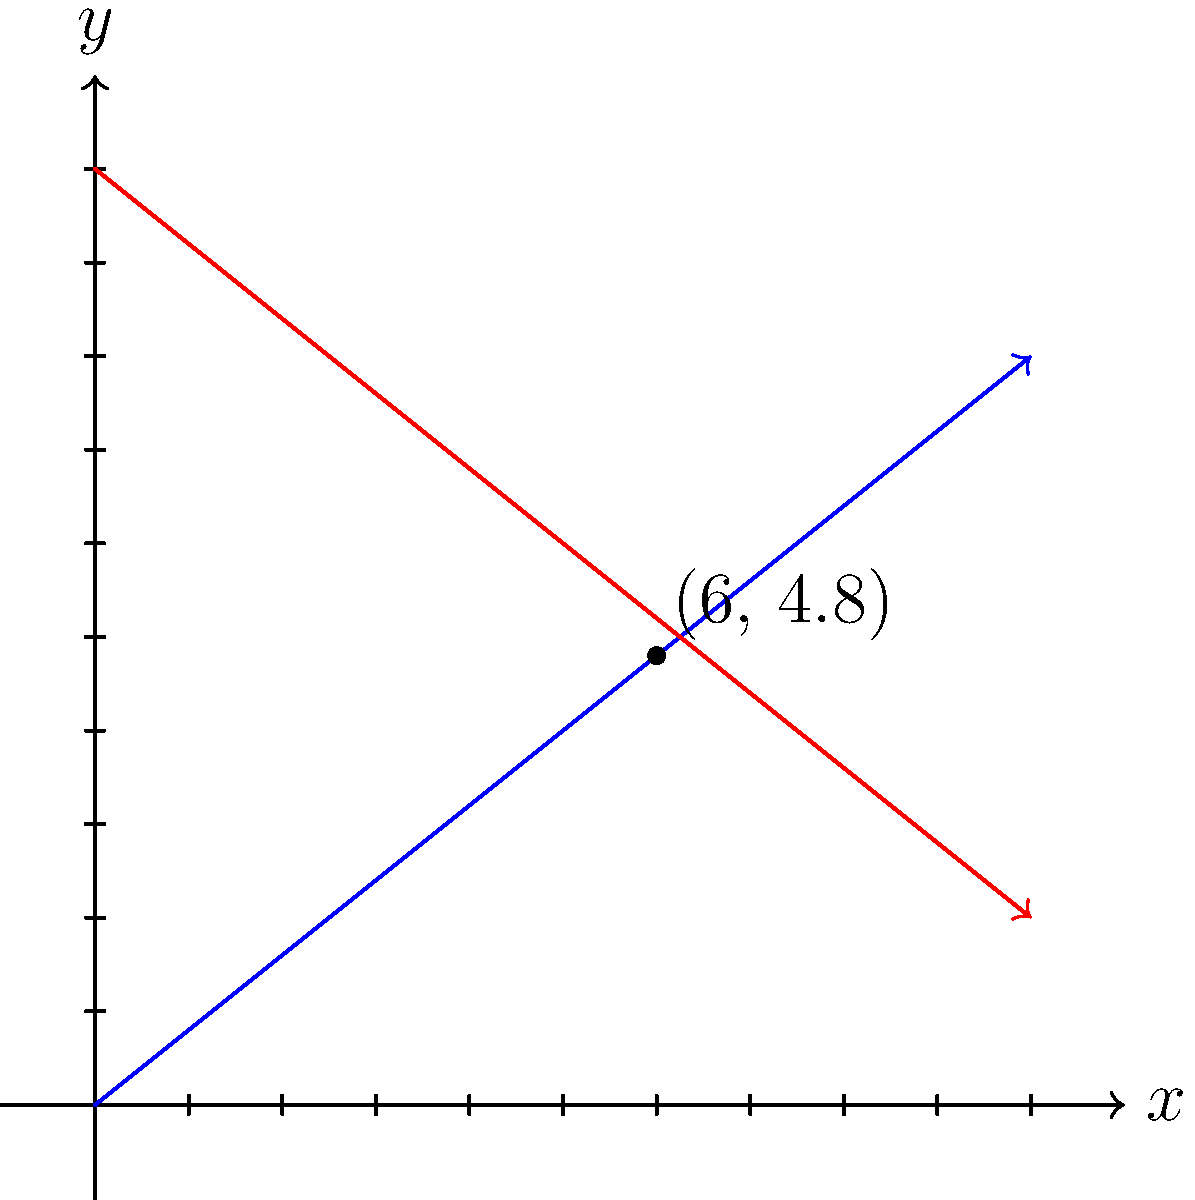Two paths are represented on a coordinate grid. The blue path starts at (0, 0) and moves towards (10, 8), while the red path begins at (0, 10) and heads towards (10, 2). To arrange a clandestine meeting between the war correspondent and a key informant, you need to determine their rendezvous point. Calculate the coordinates of the intersection point of these two paths. To find the intersection point, we need to follow these steps:

1) First, let's determine the equations of both lines:

   For the blue line:
   Slope = $m_1 = \frac{8-0}{10-0} = \frac{4}{5} = 0.8$
   Equation: $y = 0.8x$

   For the red line:
   Slope = $m_2 = \frac{2-10}{10-0} = -\frac{4}{5} = -0.8$
   Equation: $y = -0.8x + 10$

2) At the intersection point, the y-coordinates will be equal. So we can set the right sides of the equations equal to each other:

   $0.8x = -0.8x + 10$

3) Solve for x:
   $1.6x = 10$
   $x = \frac{10}{1.6} = 6.25$

4) Substitute this x-value back into either equation to find y:
   $y = 0.8(6.25) = 5$

5) Therefore, the intersection point is (6.25, 5).

6) However, for practical purposes in a real-world scenario, we might round these values to the nearest tenth:
   (6.3, 5.0)
Answer: (6.3, 5.0) 